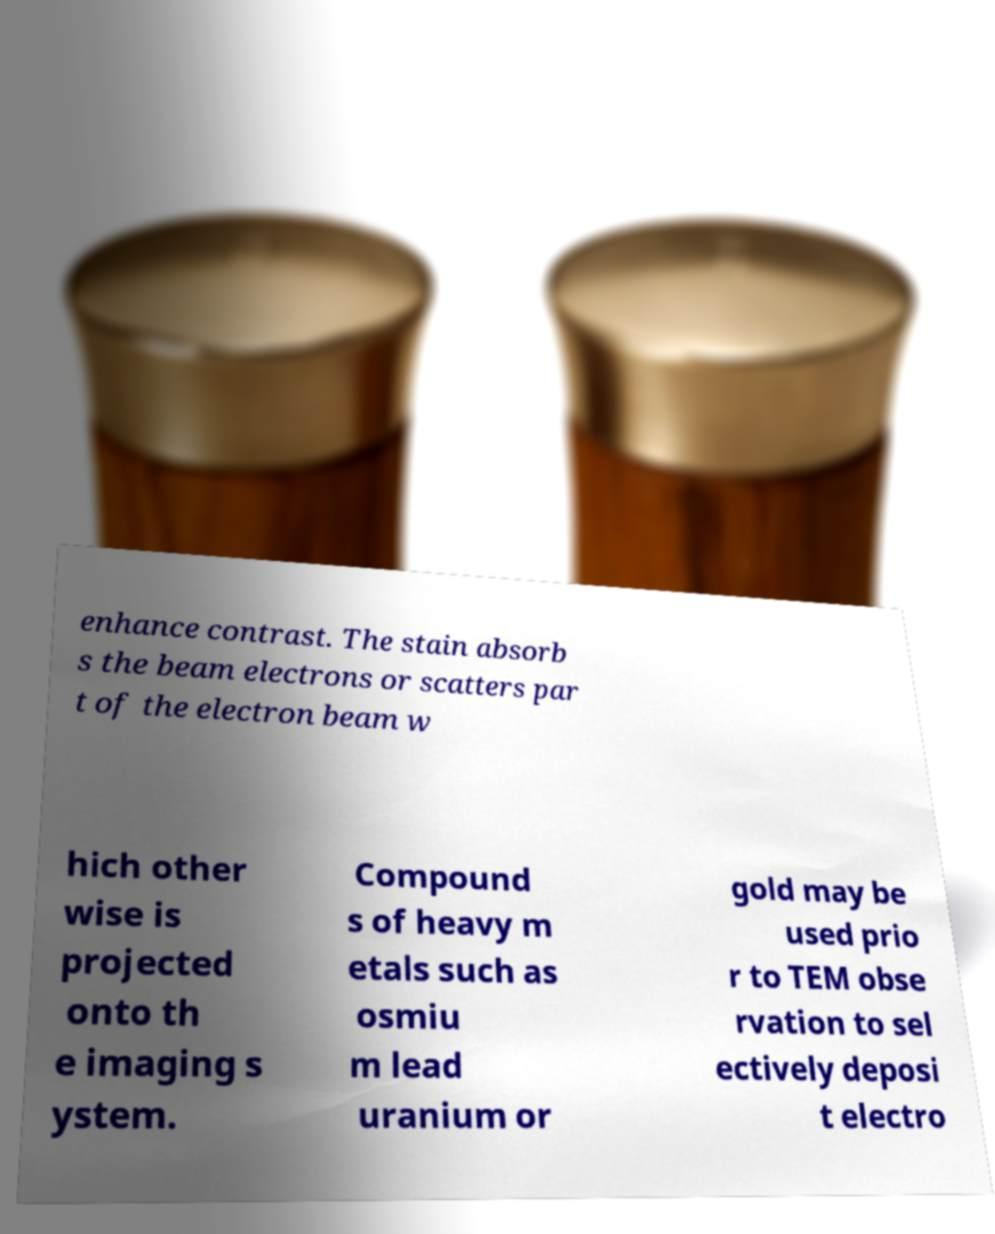Could you assist in decoding the text presented in this image and type it out clearly? enhance contrast. The stain absorb s the beam electrons or scatters par t of the electron beam w hich other wise is projected onto th e imaging s ystem. Compound s of heavy m etals such as osmiu m lead uranium or gold may be used prio r to TEM obse rvation to sel ectively deposi t electro 